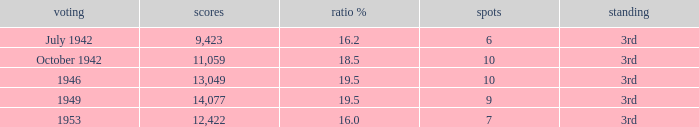Name the sum of votes % more than 19.5 None. 